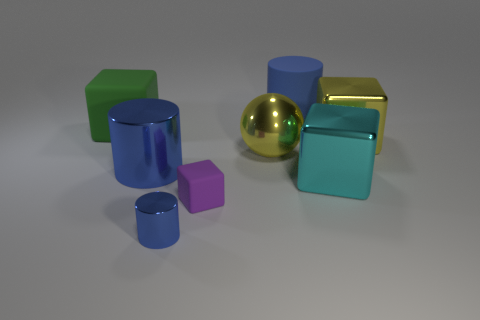The purple object has what shape? The purple object in the image is a cube, which can be identified by its equal-length sides and overall symmetry in three dimensions. Its distinct edges and flat surfaces are hallmarks of a cube's geometric characteristics. 